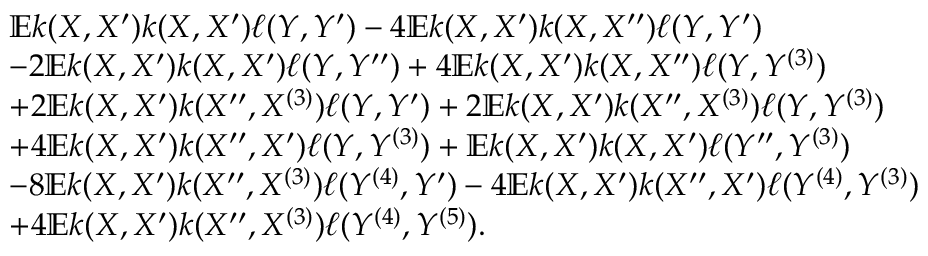Convert formula to latex. <formula><loc_0><loc_0><loc_500><loc_500>\begin{array} { r l } & { \mathbb { E } k ( X , X ^ { \prime } ) k ( X , X ^ { \prime } ) \ell ( Y , Y ^ { \prime } ) - 4 \mathbb { E } k ( X , X ^ { \prime } ) k ( X , X ^ { \prime \prime } ) \ell ( Y , Y ^ { \prime } ) } \\ & { - 2 \mathbb { E } k ( X , X ^ { \prime } ) k ( X , X ^ { \prime } ) \ell ( Y , Y ^ { \prime \prime } ) + 4 \mathbb { E } k ( X , X ^ { \prime } ) k ( X , X ^ { \prime \prime } ) \ell ( Y , Y ^ { ( 3 ) } ) } \\ & { + 2 \mathbb { E } k ( X , X ^ { \prime } ) k ( X ^ { \prime \prime } , X ^ { ( 3 ) } ) \ell ( Y , Y ^ { \prime } ) + 2 \mathbb { E } k ( X , X ^ { \prime } ) k ( X ^ { \prime \prime } , X ^ { ( 3 ) } ) \ell ( Y , Y ^ { ( 3 ) } ) } \\ & { + 4 \mathbb { E } k ( X , X ^ { \prime } ) k ( X ^ { \prime \prime } , X ^ { \prime } ) \ell ( Y , Y ^ { ( 3 ) } ) + \mathbb { E } k ( X , X ^ { \prime } ) k ( X , X ^ { \prime } ) \ell ( Y ^ { \prime \prime } , Y ^ { ( 3 ) } ) } \\ & { - 8 \mathbb { E } k ( X , X ^ { \prime } ) k ( X ^ { \prime \prime } , X ^ { ( 3 ) } ) \ell ( Y ^ { ( 4 ) } , Y ^ { \prime } ) - 4 \mathbb { E } k ( X , X ^ { \prime } ) k ( X ^ { \prime \prime } , X ^ { \prime } ) \ell ( Y ^ { ( 4 ) } , Y ^ { ( 3 ) } ) } \\ & { + 4 \mathbb { E } k ( X , X ^ { \prime } ) k ( X ^ { \prime \prime } , X ^ { ( 3 ) } ) \ell ( Y ^ { ( 4 ) } , Y ^ { ( 5 ) } ) . } \end{array}</formula> 